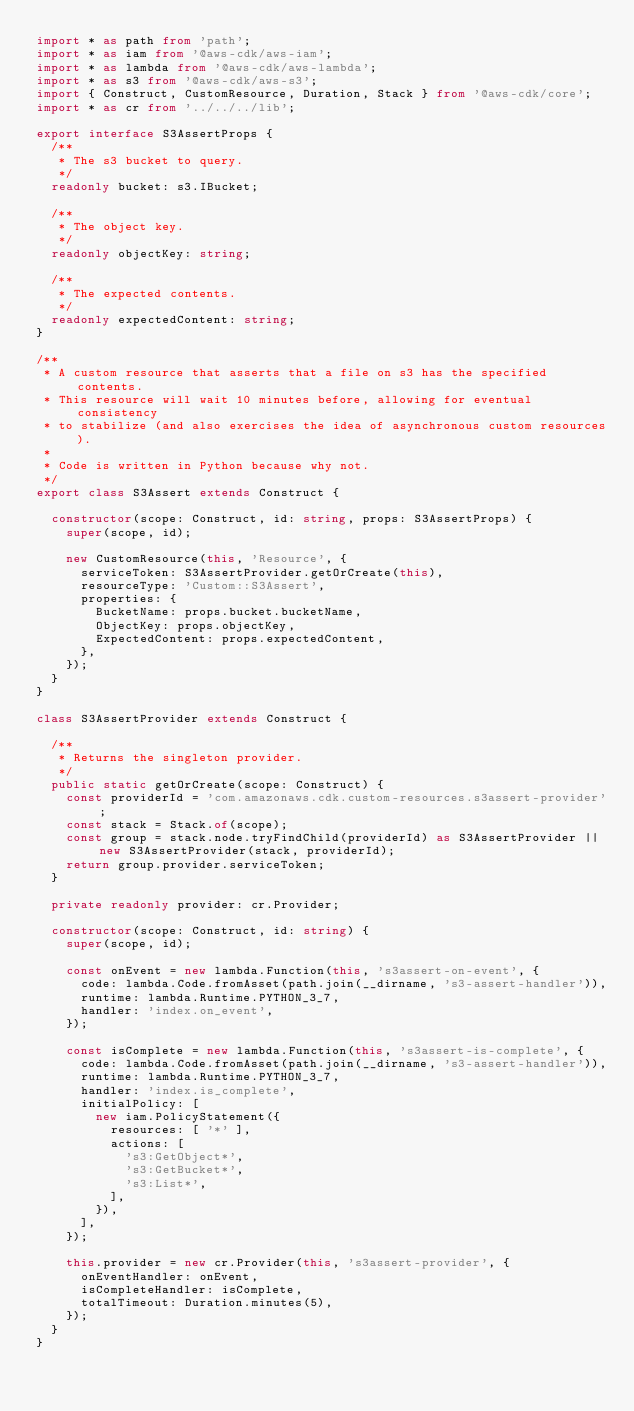<code> <loc_0><loc_0><loc_500><loc_500><_TypeScript_>import * as path from 'path';
import * as iam from '@aws-cdk/aws-iam';
import * as lambda from '@aws-cdk/aws-lambda';
import * as s3 from '@aws-cdk/aws-s3';
import { Construct, CustomResource, Duration, Stack } from '@aws-cdk/core';
import * as cr from '../../../lib';

export interface S3AssertProps {
  /**
   * The s3 bucket to query.
   */
  readonly bucket: s3.IBucket;

  /**
   * The object key.
   */
  readonly objectKey: string;

  /**
   * The expected contents.
   */
  readonly expectedContent: string;
}

/**
 * A custom resource that asserts that a file on s3 has the specified contents.
 * This resource will wait 10 minutes before, allowing for eventual consistency
 * to stabilize (and also exercises the idea of asynchronous custom resources).
 *
 * Code is written in Python because why not.
 */
export class S3Assert extends Construct {

  constructor(scope: Construct, id: string, props: S3AssertProps) {
    super(scope, id);

    new CustomResource(this, 'Resource', {
      serviceToken: S3AssertProvider.getOrCreate(this),
      resourceType: 'Custom::S3Assert',
      properties: {
        BucketName: props.bucket.bucketName,
        ObjectKey: props.objectKey,
        ExpectedContent: props.expectedContent,
      },
    });
  }
}

class S3AssertProvider extends Construct {

  /**
   * Returns the singleton provider.
   */
  public static getOrCreate(scope: Construct) {
    const providerId = 'com.amazonaws.cdk.custom-resources.s3assert-provider';
    const stack = Stack.of(scope);
    const group = stack.node.tryFindChild(providerId) as S3AssertProvider || new S3AssertProvider(stack, providerId);
    return group.provider.serviceToken;
  }

  private readonly provider: cr.Provider;

  constructor(scope: Construct, id: string) {
    super(scope, id);

    const onEvent = new lambda.Function(this, 's3assert-on-event', {
      code: lambda.Code.fromAsset(path.join(__dirname, 's3-assert-handler')),
      runtime: lambda.Runtime.PYTHON_3_7,
      handler: 'index.on_event',
    });

    const isComplete = new lambda.Function(this, 's3assert-is-complete', {
      code: lambda.Code.fromAsset(path.join(__dirname, 's3-assert-handler')),
      runtime: lambda.Runtime.PYTHON_3_7,
      handler: 'index.is_complete',
      initialPolicy: [
        new iam.PolicyStatement({
          resources: [ '*' ],
          actions: [
            's3:GetObject*',
            's3:GetBucket*',
            's3:List*',
          ],
        }),
      ],
    });

    this.provider = new cr.Provider(this, 's3assert-provider', {
      onEventHandler: onEvent,
      isCompleteHandler: isComplete,
      totalTimeout: Duration.minutes(5),
    });
  }
}
</code> 